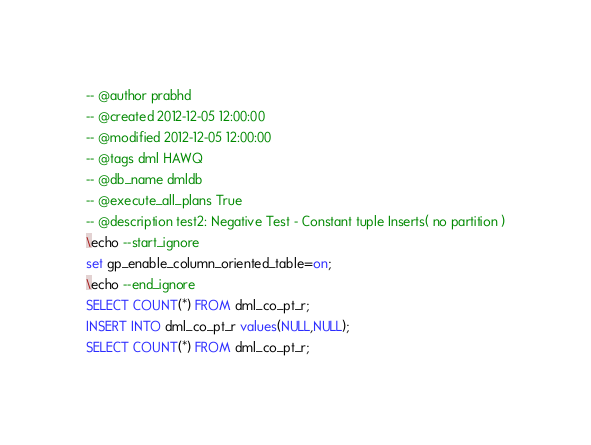Convert code to text. <code><loc_0><loc_0><loc_500><loc_500><_SQL_>-- @author prabhd 
-- @created 2012-12-05 12:00:00 
-- @modified 2012-12-05 12:00:00 
-- @tags dml HAWQ 
-- @db_name dmldb
-- @execute_all_plans True
-- @description test2: Negative Test - Constant tuple Inserts( no partition )
\echo --start_ignore
set gp_enable_column_oriented_table=on;
\echo --end_ignore
SELECT COUNT(*) FROM dml_co_pt_r;
INSERT INTO dml_co_pt_r values(NULL,NULL);
SELECT COUNT(*) FROM dml_co_pt_r;
</code> 